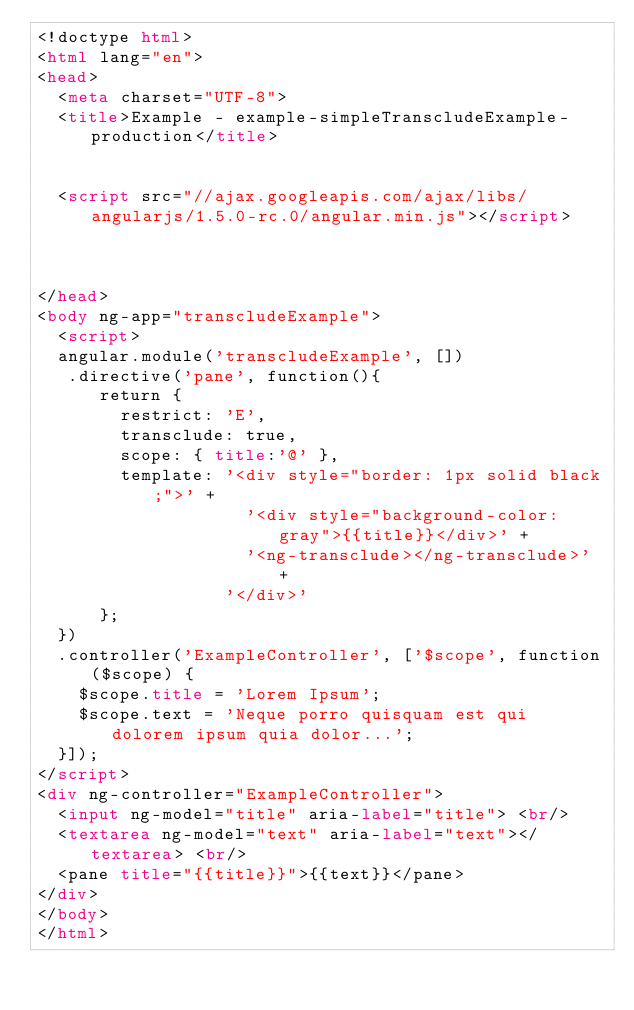<code> <loc_0><loc_0><loc_500><loc_500><_HTML_><!doctype html>
<html lang="en">
<head>
  <meta charset="UTF-8">
  <title>Example - example-simpleTranscludeExample-production</title>
  

  <script src="//ajax.googleapis.com/ajax/libs/angularjs/1.5.0-rc.0/angular.min.js"></script>
  

  
</head>
<body ng-app="transcludeExample">
  <script>
  angular.module('transcludeExample', [])
   .directive('pane', function(){
      return {
        restrict: 'E',
        transclude: true,
        scope: { title:'@' },
        template: '<div style="border: 1px solid black;">' +
                    '<div style="background-color: gray">{{title}}</div>' +
                    '<ng-transclude></ng-transclude>' +
                  '</div>'
      };
  })
  .controller('ExampleController', ['$scope', function($scope) {
    $scope.title = 'Lorem Ipsum';
    $scope.text = 'Neque porro quisquam est qui dolorem ipsum quia dolor...';
  }]);
</script>
<div ng-controller="ExampleController">
  <input ng-model="title" aria-label="title"> <br/>
  <textarea ng-model="text" aria-label="text"></textarea> <br/>
  <pane title="{{title}}">{{text}}</pane>
</div>
</body>
</html></code> 